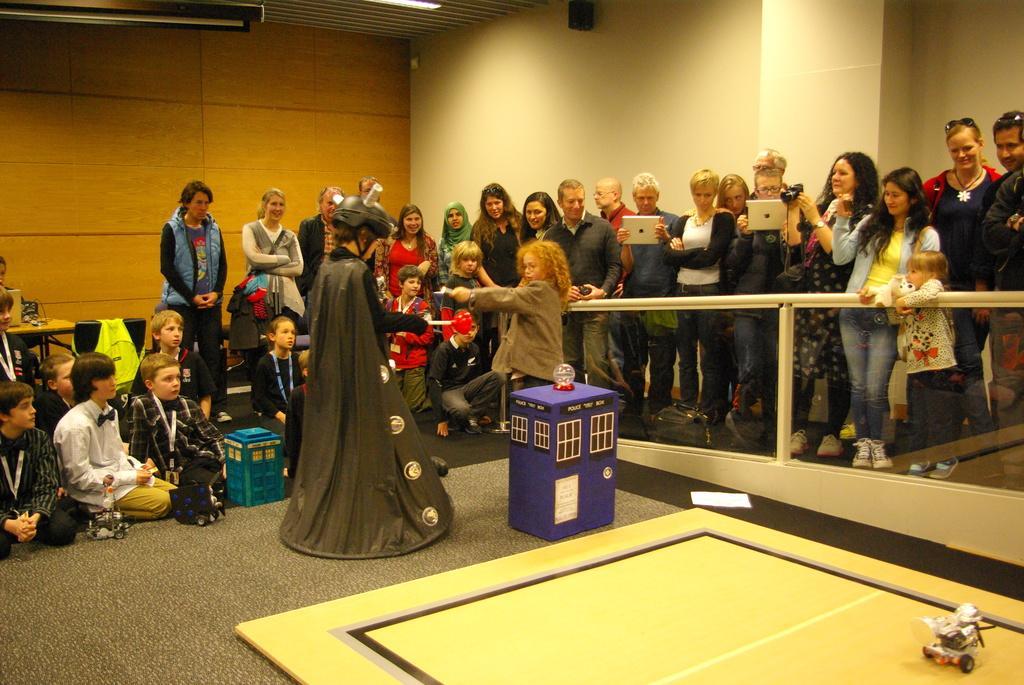Can you describe this image briefly? At the bottom of the picture we can see mat and toy. In the middle of the picture there are people, kids, toys, table, backpack and hand railing. In the background it is well. At the top there is ceiling. 